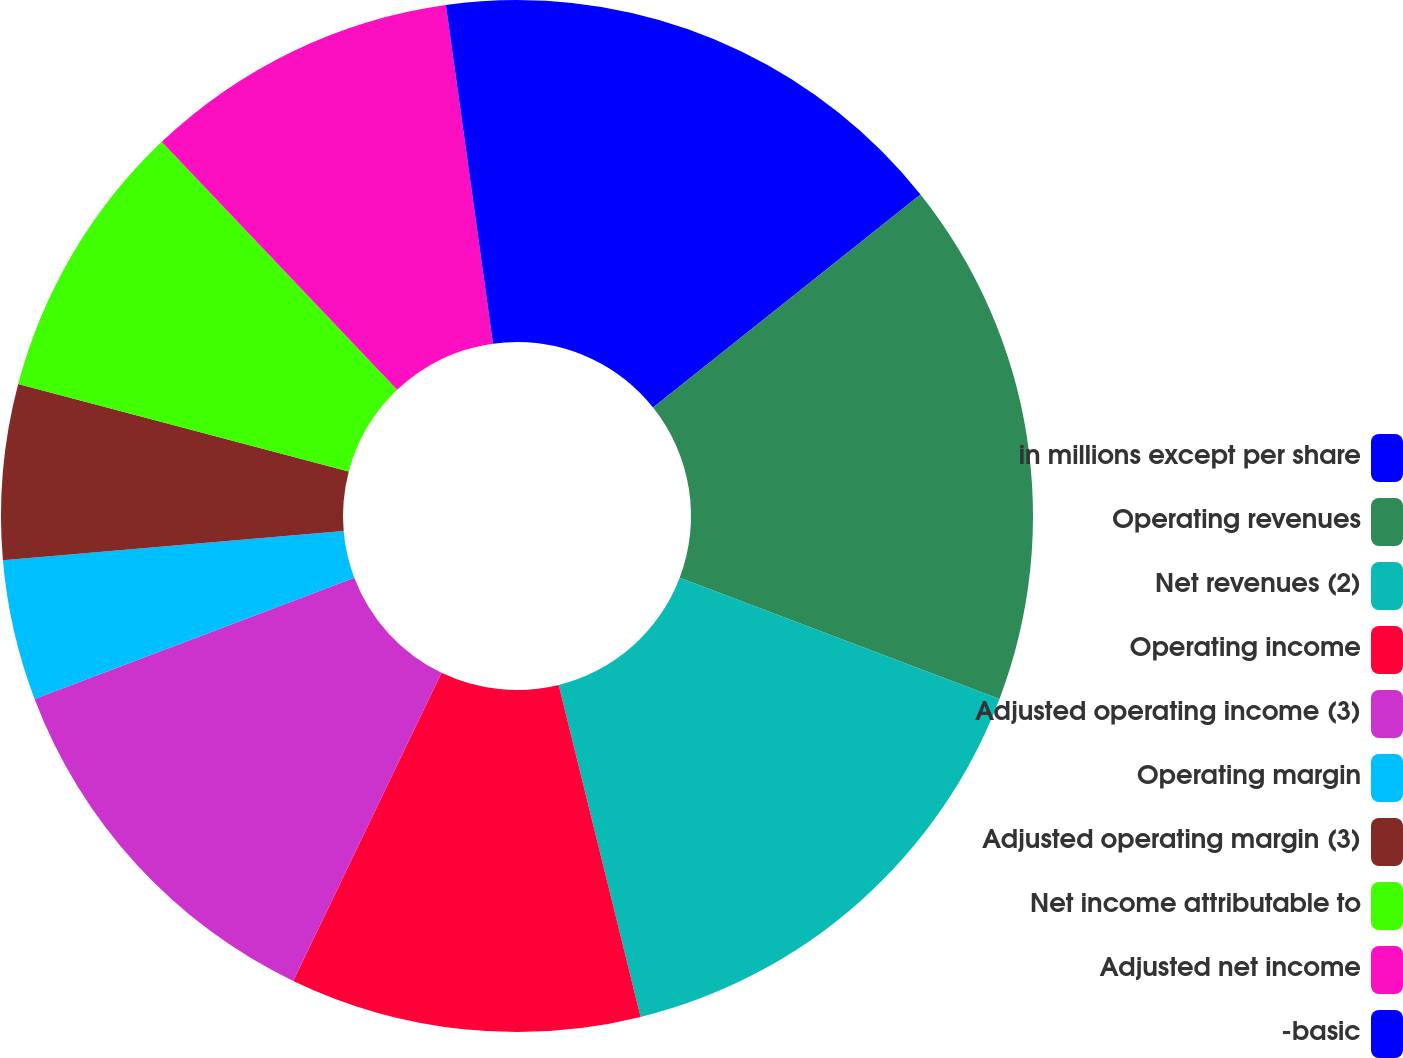Convert chart to OTSL. <chart><loc_0><loc_0><loc_500><loc_500><pie_chart><fcel>in millions except per share<fcel>Operating revenues<fcel>Net revenues (2)<fcel>Operating income<fcel>Adjusted operating income (3)<fcel>Operating margin<fcel>Adjusted operating margin (3)<fcel>Net income attributable to<fcel>Adjusted net income<fcel>-basic<nl><fcel>14.29%<fcel>16.48%<fcel>15.38%<fcel>10.99%<fcel>12.09%<fcel>4.4%<fcel>5.49%<fcel>8.79%<fcel>9.89%<fcel>2.2%<nl></chart> 